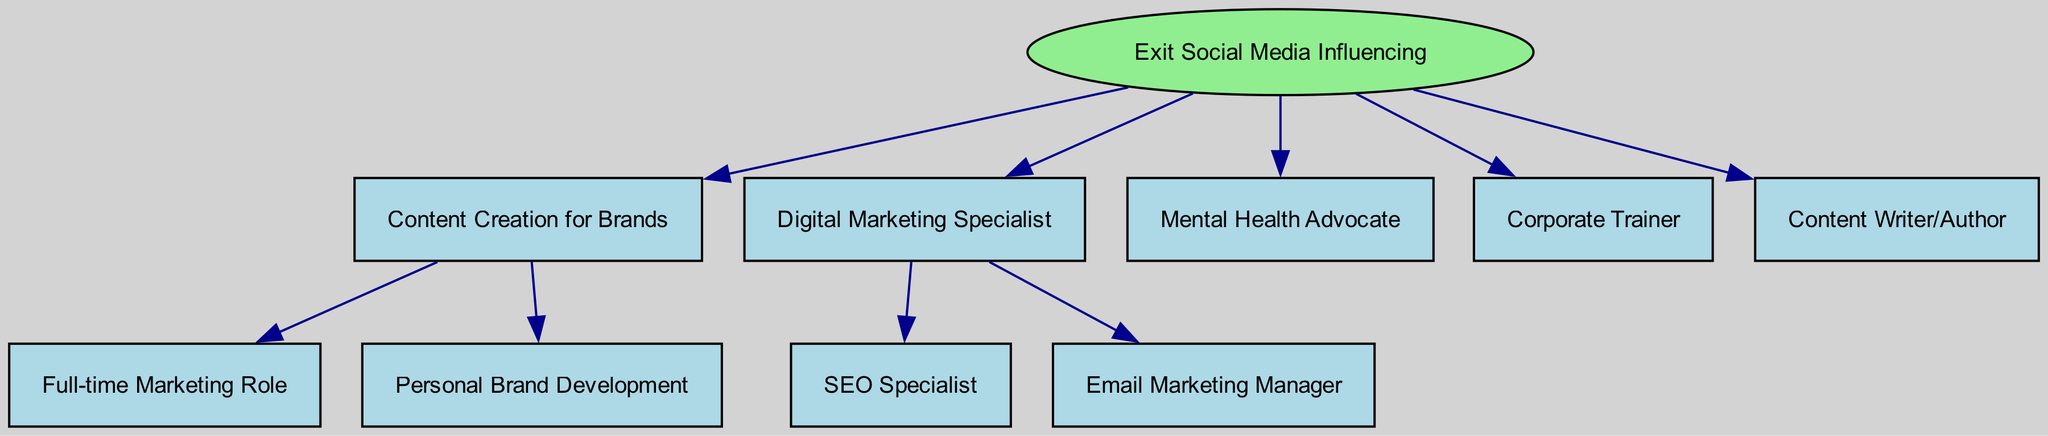What is the starting transition in the diagram? The starting transition in the diagram is "Exit Social Media Influencing," as indicated in the "Start" node.
Answer: Exit Social Media Influencing How many outcomes are listed under the "Exit Social Media Influencing"? There are five outcomes listed under the "Exit Social Media Influencing," which are various career paths available after leaving social media influencing.
Answer: 5 What is one possible next step after "Content Creation for Brands"? One possible next step is "Full-time Marketing Role," as this is one of the options listed under the "Content Creation for Brands" outcome.
Answer: Full-time Marketing Role Which path focuses on managing digital campaigns? The path that focuses on managing digital campaigns is "Digital Marketing Specialist," as described in the diagram.
Answer: Digital Marketing Specialist What is the relationship between "Mental Health Advocate" and "Content Creation for Brands"? "Mental Health Advocate" is a separate outcome under the "Exit Social Media Influencing" transition, while "Content Creation for Brands" is another distinct outcome; they are not directly related.
Answer: Separate outcomes If someone chooses "SEO Specialist," what was their previous career path? If someone chooses "SEO Specialist," their previous career path was "Digital Marketing Specialist," as it is the only path leading to SEO Specialist within the diagram.
Answer: Digital Marketing Specialist What is the main focus of the "Corporate Trainer" path? The main focus of the "Corporate Trainer" path is to train teams on effective social media usage and personal branding strategies, as provided in its description.
Answer: Training teams How does the "Content Writer/Author" differ from "Mental Health Advocate"? "Content Writer/Author" involves writing books or articles about experiences in social media, while "Mental Health Advocate" is about sharing insights on mental health issues related to social media; they focus on different aspects of the individual's experience.
Answer: Different focuses 